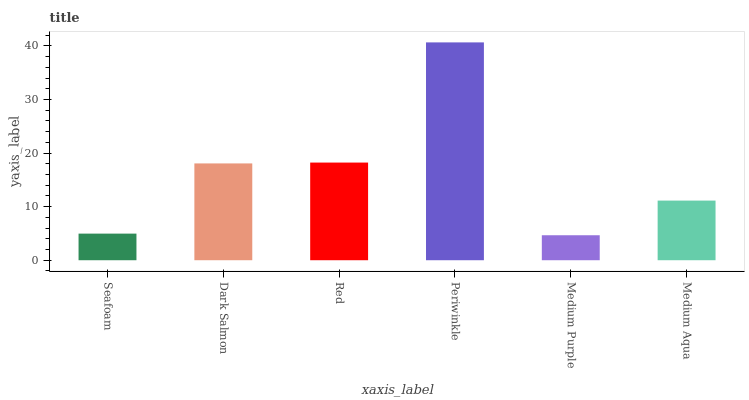Is Medium Purple the minimum?
Answer yes or no. Yes. Is Periwinkle the maximum?
Answer yes or no. Yes. Is Dark Salmon the minimum?
Answer yes or no. No. Is Dark Salmon the maximum?
Answer yes or no. No. Is Dark Salmon greater than Seafoam?
Answer yes or no. Yes. Is Seafoam less than Dark Salmon?
Answer yes or no. Yes. Is Seafoam greater than Dark Salmon?
Answer yes or no. No. Is Dark Salmon less than Seafoam?
Answer yes or no. No. Is Dark Salmon the high median?
Answer yes or no. Yes. Is Medium Aqua the low median?
Answer yes or no. Yes. Is Red the high median?
Answer yes or no. No. Is Medium Purple the low median?
Answer yes or no. No. 